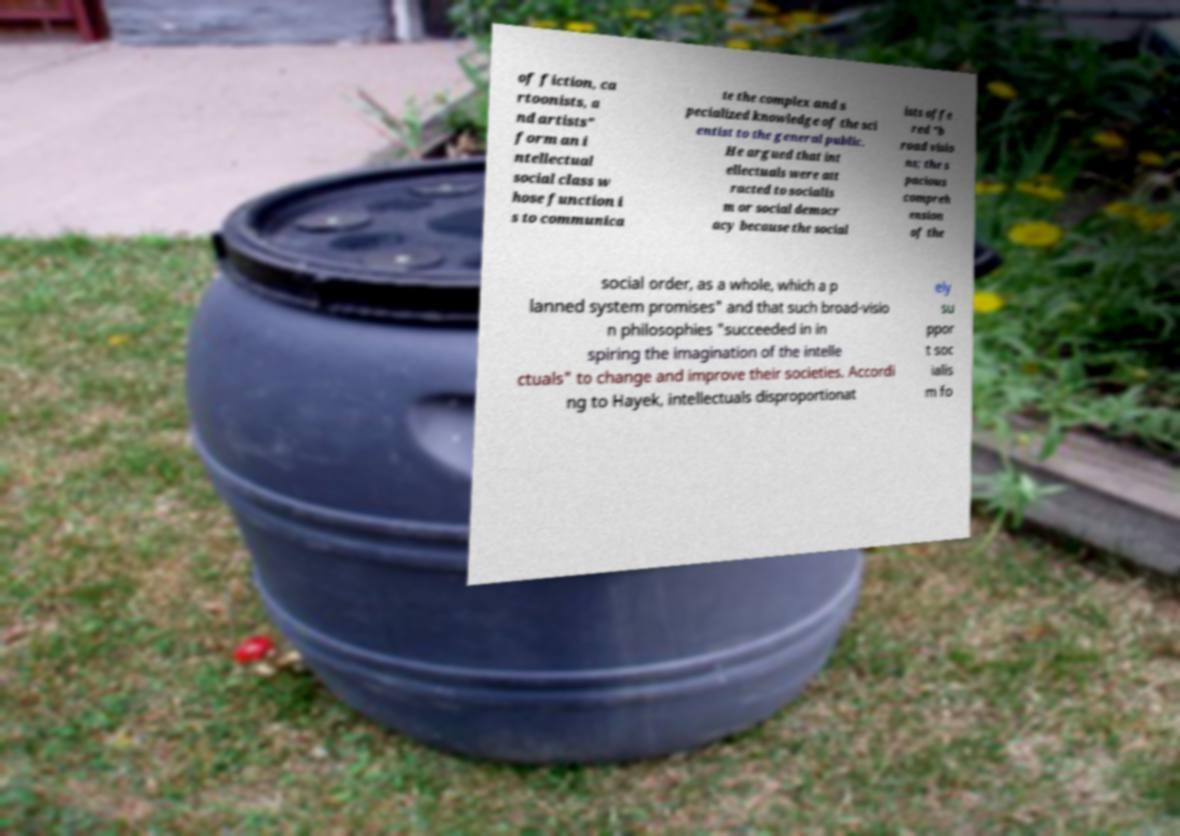Can you accurately transcribe the text from the provided image for me? of fiction, ca rtoonists, a nd artists" form an i ntellectual social class w hose function i s to communica te the complex and s pecialized knowledge of the sci entist to the general public. He argued that int ellectuals were att racted to socialis m or social democr acy because the social ists offe red "b road visio ns; the s pacious compreh ension of the social order, as a whole, which a p lanned system promises" and that such broad-visio n philosophies "succeeded in in spiring the imagination of the intelle ctuals" to change and improve their societies. Accordi ng to Hayek, intellectuals disproportionat ely su ppor t soc ialis m fo 